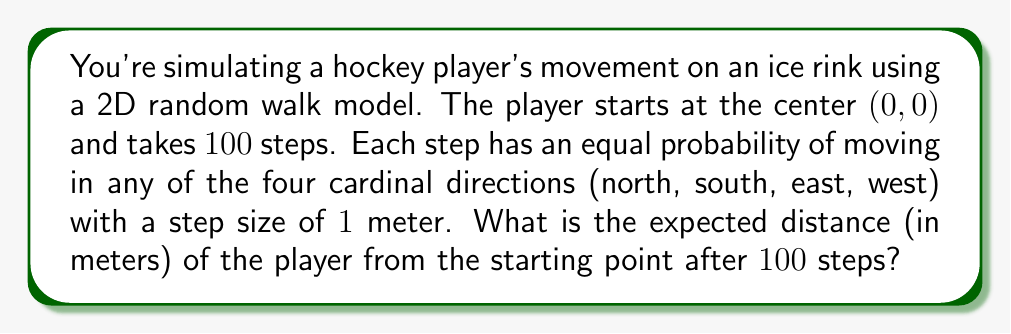Can you answer this question? Let's approach this step-by-step:

1) In a 2D random walk, the expected squared distance from the origin after $n$ steps is given by:

   $$E[R^2] = n \cdot a^2$$

   Where $R$ is the distance from the origin, $n$ is the number of steps, and $a$ is the step size.

2) In this case:
   $n = 100$ steps
   $a = 1$ meter

3) Substituting these values:

   $$E[R^2] = 100 \cdot 1^2 = 100$$

4) However, we're asked for the expected distance $E[R]$, not the expected squared distance $E[R^2]$.

5) For a 2D random walk, the relationship between $E[R]$ and $E[R^2]$ is:

   $$E[R] \approx \sqrt{\frac{\pi}{4} \cdot E[R^2]}$$

6) Substituting our value for $E[R^2]$:

   $$E[R] \approx \sqrt{\frac{\pi}{4} \cdot 100}$$

7) Calculating this:

   $$E[R] \approx \sqrt{78.54} \approx 8.86$$

Therefore, after 100 steps, the expected distance of the player from the starting point is approximately 8.86 meters.
Answer: 8.86 meters 